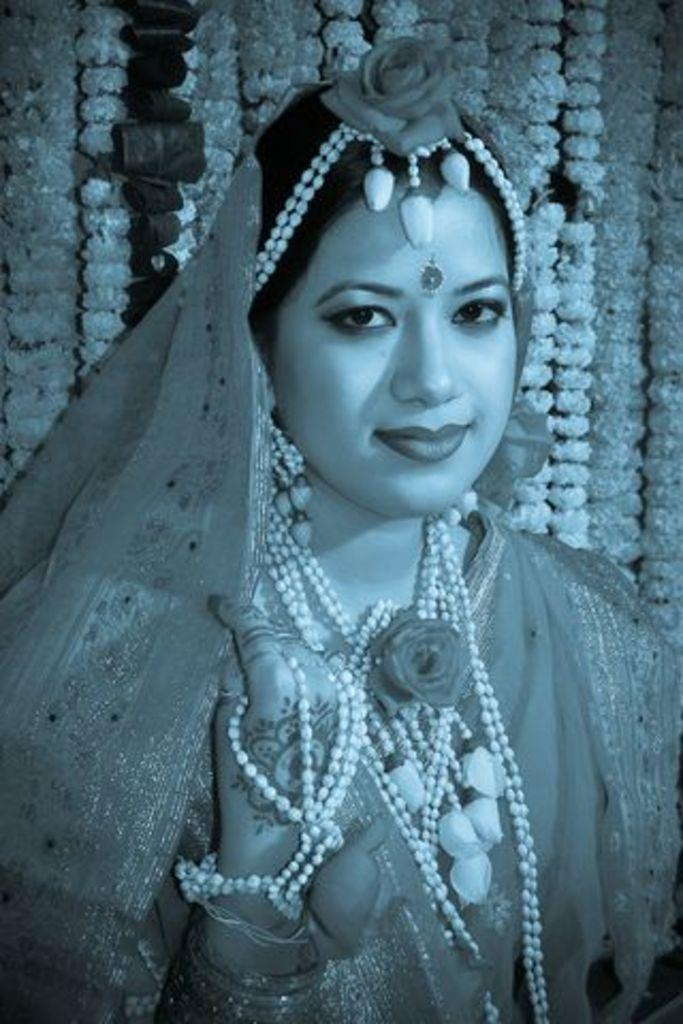Who is present in the image? There is a woman in the image. What expression does the woman have? The woman is smiling. What can be seen in the background of the image? There are flower garlands in the background of the image. What type of patch is visible on the woman's arm in the image? There is no patch visible on the woman's arm in the image. 